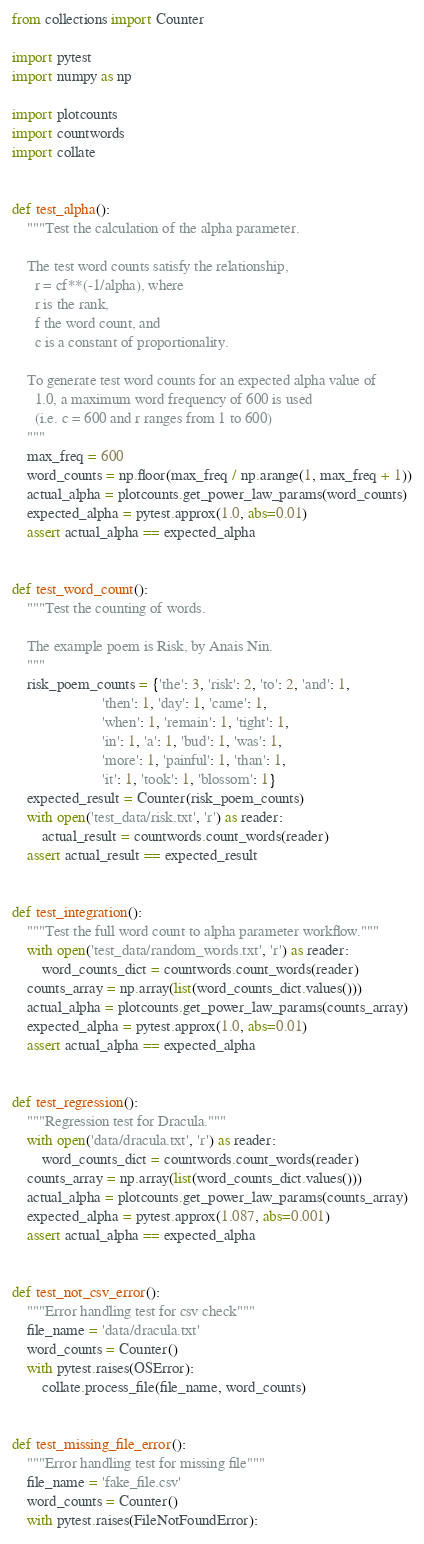Convert code to text. <code><loc_0><loc_0><loc_500><loc_500><_Python_>from collections import Counter

import pytest
import numpy as np

import plotcounts
import countwords
import collate


def test_alpha():
    """Test the calculation of the alpha parameter.

    The test word counts satisfy the relationship,
      r = cf**(-1/alpha), where
      r is the rank,
      f the word count, and
      c is a constant of proportionality.

    To generate test word counts for an expected alpha value of
      1.0, a maximum word frequency of 600 is used
      (i.e. c = 600 and r ranges from 1 to 600)
    """
    max_freq = 600
    word_counts = np.floor(max_freq / np.arange(1, max_freq + 1))
    actual_alpha = plotcounts.get_power_law_params(word_counts)
    expected_alpha = pytest.approx(1.0, abs=0.01)
    assert actual_alpha == expected_alpha


def test_word_count():
    """Test the counting of words.

    The example poem is Risk, by Anais Nin.
    """
    risk_poem_counts = {'the': 3, 'risk': 2, 'to': 2, 'and': 1,
                        'then': 1, 'day': 1, 'came': 1,
                        'when': 1, 'remain': 1, 'tight': 1,
                        'in': 1, 'a': 1, 'bud': 1, 'was': 1,
                        'more': 1, 'painful': 1, 'than': 1,
                        'it': 1, 'took': 1, 'blossom': 1}
    expected_result = Counter(risk_poem_counts)
    with open('test_data/risk.txt', 'r') as reader:
        actual_result = countwords.count_words(reader)
    assert actual_result == expected_result


def test_integration():
    """Test the full word count to alpha parameter workflow."""
    with open('test_data/random_words.txt', 'r') as reader:
        word_counts_dict = countwords.count_words(reader)
    counts_array = np.array(list(word_counts_dict.values()))
    actual_alpha = plotcounts.get_power_law_params(counts_array)
    expected_alpha = pytest.approx(1.0, abs=0.01)
    assert actual_alpha == expected_alpha


def test_regression():
    """Regression test for Dracula."""
    with open('data/dracula.txt', 'r') as reader:
        word_counts_dict = countwords.count_words(reader)
    counts_array = np.array(list(word_counts_dict.values()))
    actual_alpha = plotcounts.get_power_law_params(counts_array)
    expected_alpha = pytest.approx(1.087, abs=0.001)
    assert actual_alpha == expected_alpha


def test_not_csv_error():
    """Error handling test for csv check"""
    file_name = 'data/dracula.txt'
    word_counts = Counter()
    with pytest.raises(OSError):
        collate.process_file(file_name, word_counts)


def test_missing_file_error():
    """Error handling test for missing file"""
    file_name = 'fake_file.csv'
    word_counts = Counter()
    with pytest.raises(FileNotFoundError):</code> 